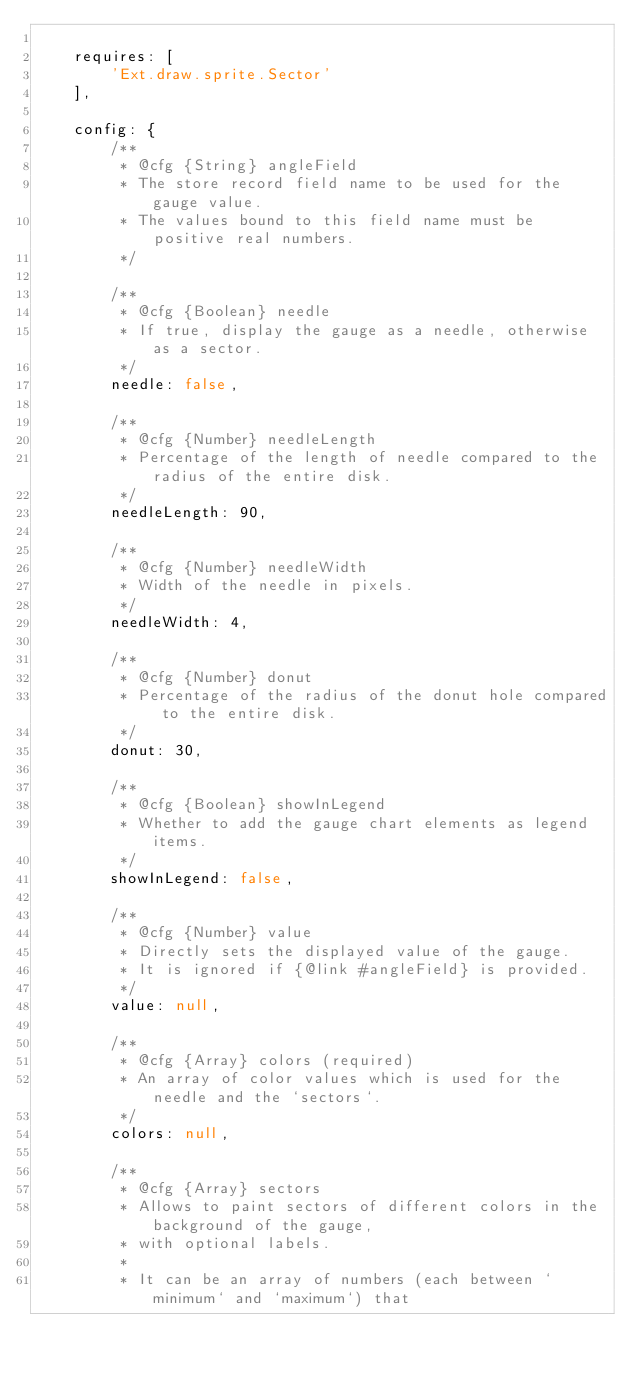Convert code to text. <code><loc_0><loc_0><loc_500><loc_500><_JavaScript_>
    requires: [
        'Ext.draw.sprite.Sector'
    ],

    config: {
        /**
         * @cfg {String} angleField
         * The store record field name to be used for the gauge value.
         * The values bound to this field name must be positive real numbers.
         */

        /**
         * @cfg {Boolean} needle
         * If true, display the gauge as a needle, otherwise as a sector.
         */
        needle: false,

        /**
         * @cfg {Number} needleLength
         * Percentage of the length of needle compared to the radius of the entire disk.
         */
        needleLength: 90,

        /**
         * @cfg {Number} needleWidth
         * Width of the needle in pixels.
         */
        needleWidth: 4,

        /**
         * @cfg {Number} donut
         * Percentage of the radius of the donut hole compared to the entire disk.
         */
        donut: 30,

        /**
         * @cfg {Boolean} showInLegend
         * Whether to add the gauge chart elements as legend items.
         */
        showInLegend: false,

        /**
         * @cfg {Number} value
         * Directly sets the displayed value of the gauge.
         * It is ignored if {@link #angleField} is provided.
         */
        value: null,

        /**
         * @cfg {Array} colors (required)
         * An array of color values which is used for the needle and the `sectors`.
         */
        colors: null,

        /**
         * @cfg {Array} sectors
         * Allows to paint sectors of different colors in the background of the gauge,
         * with optional labels.
         *
         * It can be an array of numbers (each between `minimum` and `maximum`) that</code> 